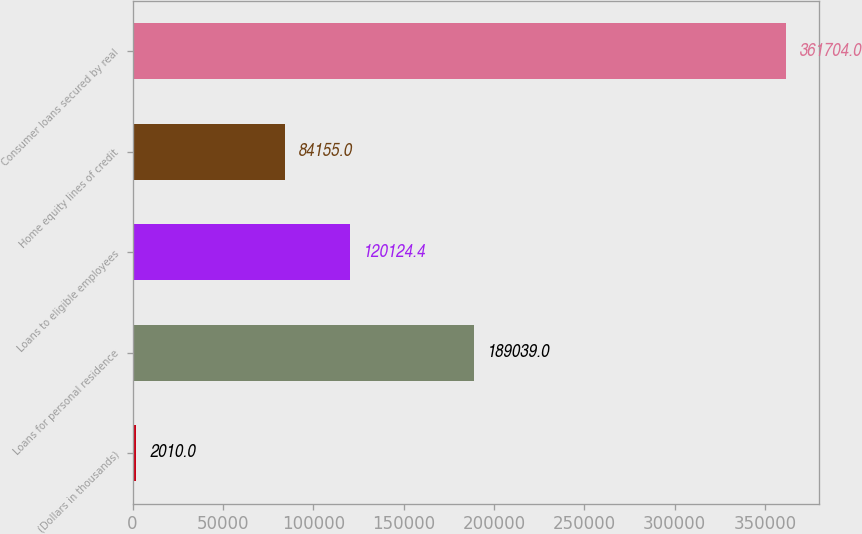Convert chart. <chart><loc_0><loc_0><loc_500><loc_500><bar_chart><fcel>(Dollars in thousands)<fcel>Loans for personal residence<fcel>Loans to eligible employees<fcel>Home equity lines of credit<fcel>Consumer loans secured by real<nl><fcel>2010<fcel>189039<fcel>120124<fcel>84155<fcel>361704<nl></chart> 